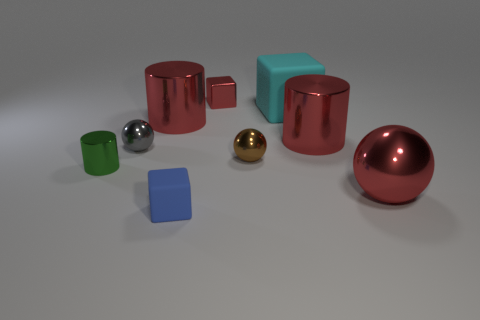What is the color of the small cylinder?
Provide a short and direct response. Green. What material is the red cylinder that is left of the tiny metal block?
Keep it short and to the point. Metal. There is a tiny gray object; is it the same shape as the matte thing that is behind the red ball?
Make the answer very short. No. Is the number of metal balls greater than the number of big cylinders?
Your answer should be very brief. Yes. Is there anything else that has the same color as the small shiny cylinder?
Offer a terse response. No. There is a gray thing that is the same material as the large sphere; what is its shape?
Your answer should be very brief. Sphere. What material is the big red cylinder on the right side of the object behind the big cyan block?
Provide a succinct answer. Metal. There is a red metal thing to the left of the small blue matte thing; is its shape the same as the small brown metal object?
Your answer should be very brief. No. Are there more gray things in front of the blue rubber block than cyan rubber things?
Offer a terse response. No. Is there any other thing that is made of the same material as the cyan object?
Give a very brief answer. Yes. 